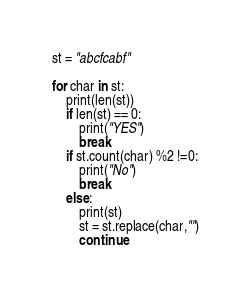<code> <loc_0><loc_0><loc_500><loc_500><_Python_>st = "abcfcabf"

for char in st:
    print(len(st))
    if len(st) == 0:
        print("YES")
        break
    if st.count(char) %2 !=0:
        print("No")
        break
    else:
        print(st)
        st = st.replace(char,"")
        continue</code> 